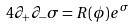<formula> <loc_0><loc_0><loc_500><loc_500>4 \partial _ { + } \partial _ { - } \sigma = R ( \phi ) e ^ { \sigma }</formula> 